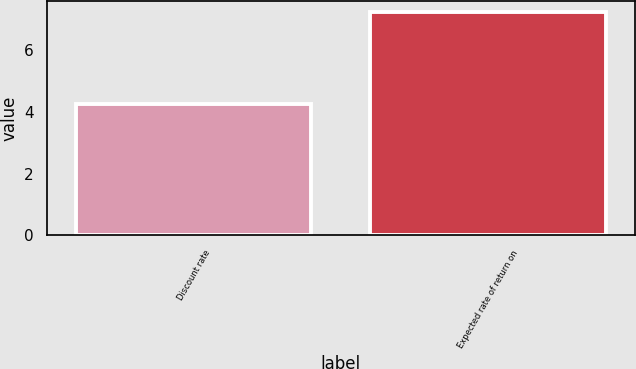<chart> <loc_0><loc_0><loc_500><loc_500><bar_chart><fcel>Discount rate<fcel>Expected rate of return on<nl><fcel>4.25<fcel>7.25<nl></chart> 